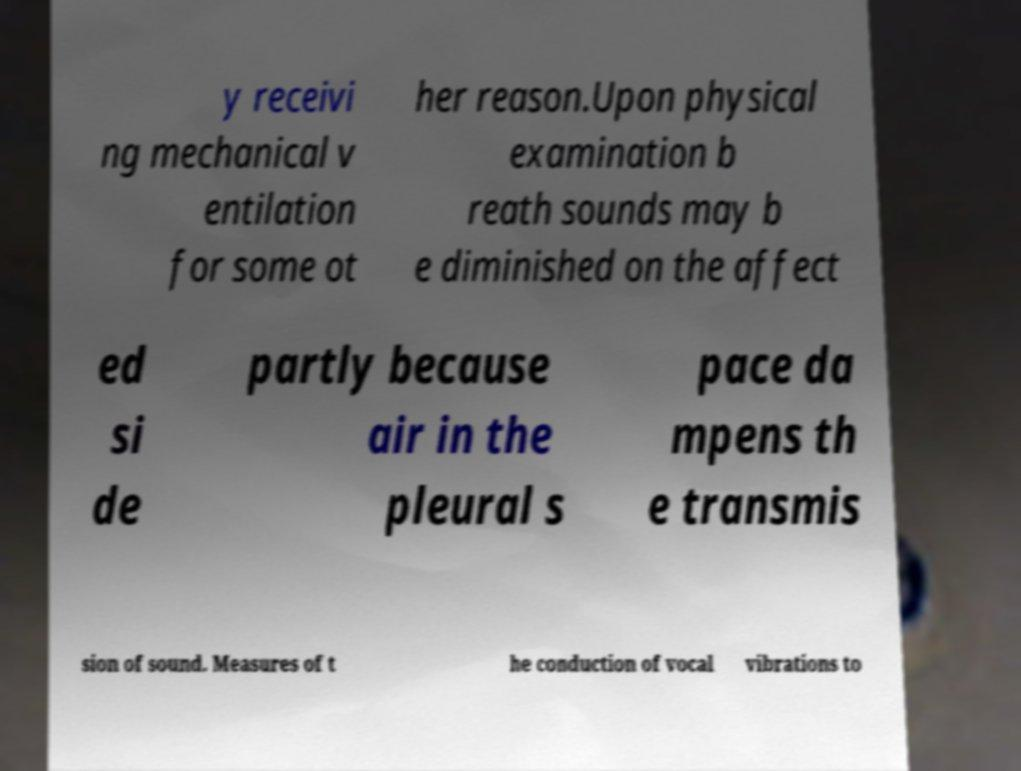I need the written content from this picture converted into text. Can you do that? y receivi ng mechanical v entilation for some ot her reason.Upon physical examination b reath sounds may b e diminished on the affect ed si de partly because air in the pleural s pace da mpens th e transmis sion of sound. Measures of t he conduction of vocal vibrations to 